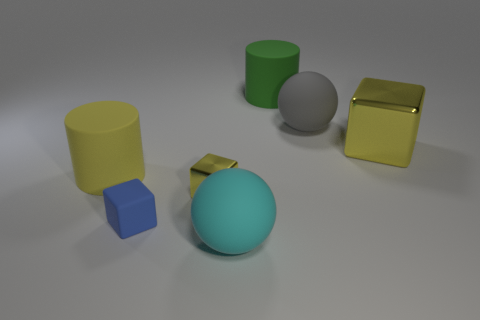Add 3 green matte things. How many objects exist? 10 Subtract all spheres. How many objects are left? 5 Subtract all large green balls. Subtract all gray matte things. How many objects are left? 6 Add 5 green matte cylinders. How many green matte cylinders are left? 6 Add 4 tiny objects. How many tiny objects exist? 6 Subtract 0 yellow balls. How many objects are left? 7 